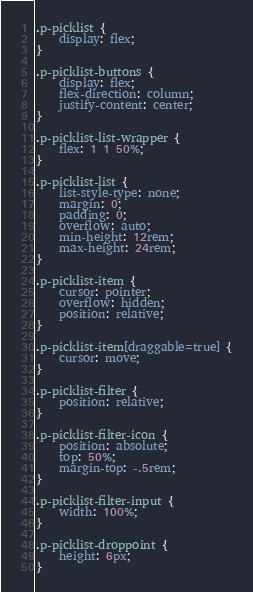<code> <loc_0><loc_0><loc_500><loc_500><_CSS_>.p-picklist {
    display: flex;
}

.p-picklist-buttons {
    display: flex;
    flex-direction: column;
    justify-content: center;
}

.p-picklist-list-wrapper {
    flex: 1 1 50%;
}

.p-picklist-list {
    list-style-type: none;
    margin: 0;
    padding: 0;
    overflow: auto;
    min-height: 12rem;
    max-height: 24rem;
}

.p-picklist-item {
    cursor: pointer;
    overflow: hidden;
    position: relative;
}

.p-picklist-item[draggable=true] {
    cursor: move;
}

.p-picklist-filter {
    position: relative;
}

.p-picklist-filter-icon {
    position: absolute;
    top: 50%;
    margin-top: -.5rem;
}

.p-picklist-filter-input {
    width: 100%;
}

.p-picklist-droppoint {
    height: 6px;
}</code> 